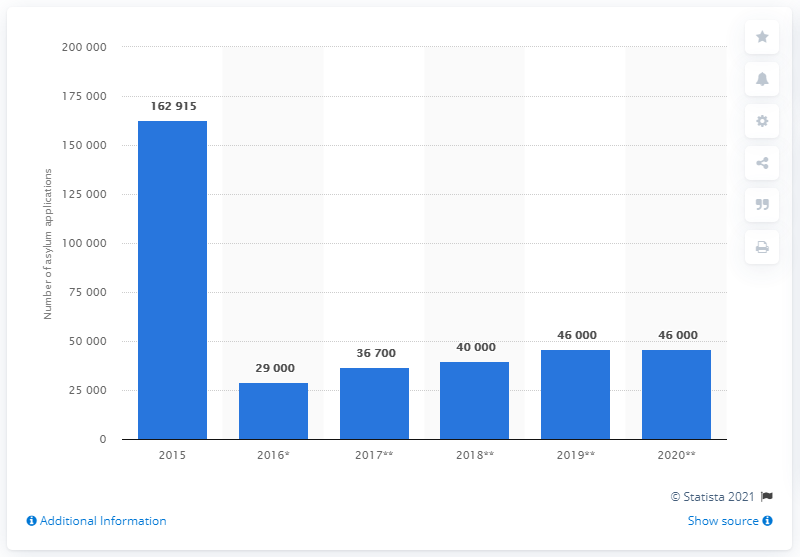Identify some key points in this picture. In 2015, a total of 162,915 asylum applications were made in Sweden. 